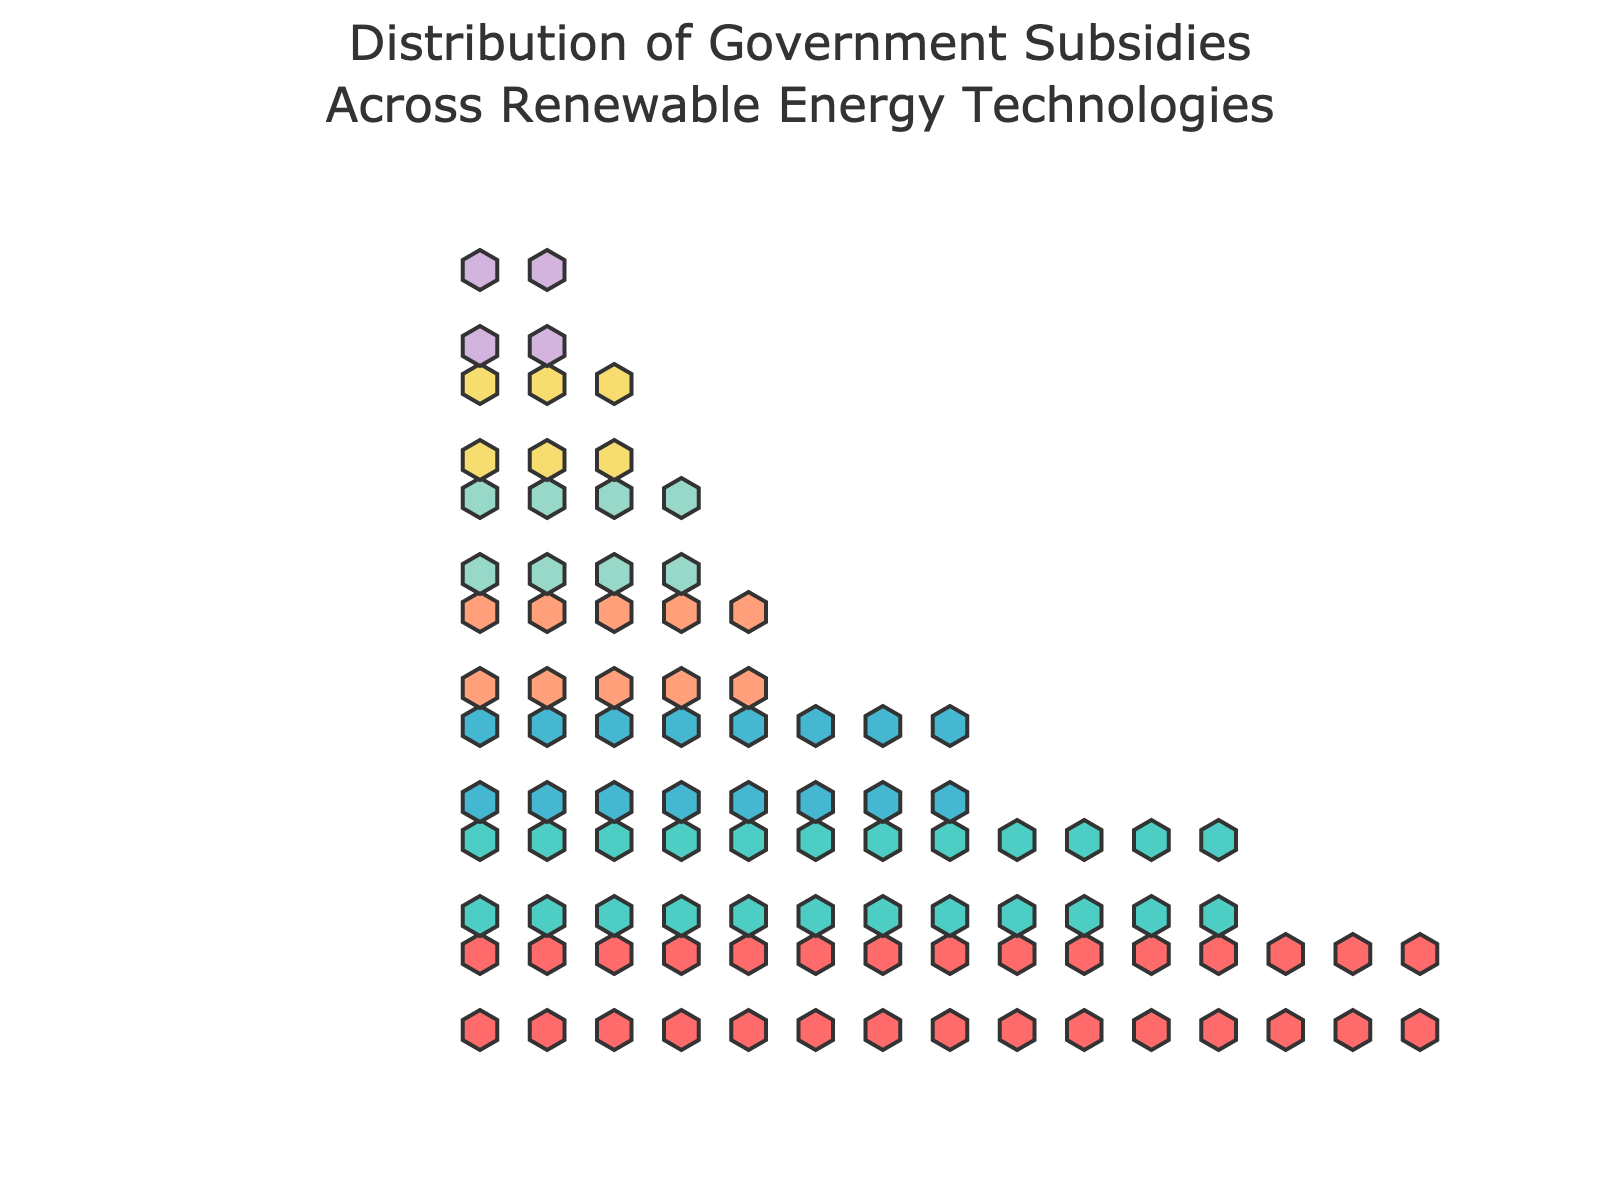What's the title of the figure? The title is written at the top of the figure, and it reads "Distribution of Government Subsidies Across Renewable Energy Technologies."
Answer: Distribution of Government Subsidies Across Renewable Energy Technologies Which technology receives the highest subsidy? Comparing all the technologies, the one with the greatest number of hexagons (each representing $1,000) signifies the highest subsidy amount. Solar has the most hexagons at 15.
Answer: Solar How many hexagons represent the subsidy for Biomass? By counting the hexagons associated with Biomass, which is indicated next to its label on the vertical axis, we find 4 hexagons.
Answer: 4 What's the combined subsidy amount for Geothermal, Biomass, and Tidal? Adding the subsidies for Geothermal ($5,000), Biomass ($4,000), and Tidal ($3,000), the total sum is calculated as $5,000 + $4,000 + $3,000 = $12,000.
Answer: $12,000 Which two technologies have the closest subsidy amounts? By examining the figure, we see that Biomass ($4,000) and Tidal ($3,000) have subsidies that are closest in value, differing by only $1,000.
Answer: Biomass and Tidal What is the difference in subsidy amounts between Wind and Hydrogen? Wind has a subsidy amount of $12,000 and Hydrogen $2,000. The difference is calculated as $12,000 - $2,000 = $10,000.
Answer: $10,000 How many hexagons are there in total in the figure? Sum the hexagons for all technologies: 15 (Solar) + 12 (Wind) + 8 (Hydroelectric) + 5 (Geothermal) + 4 (Biomass) + 3 (Tidal) + 2 (Hydrogen) = 49 hexagons.
Answer: 49 Which technology has twice the subsidy amount of Hydrogen? Hydrogen has a subsidy amount of $2,000. Geothermal has a subsidy amount of $5,000, which is more than twice but the closest. We can check Biomass ($4,000) which is exactly double. Therefore, Biomass has twice the subsidy amount of Hydrogen.
Answer: Biomass How does the subsidy for Hydroelectric compare with that of Solar? Hydroelectric has $8,000 and Solar has $15,000. Thus, Solar receives significantly more subsidy, exactly $7,000 more than Hydroelectric.
Answer: Solar receives $7,000 more What does each hexagon represent in the figure? The annotation at the bottom of the figure clarifies that each hexagon represents $1,000 in subsidies.
Answer: $1,000 